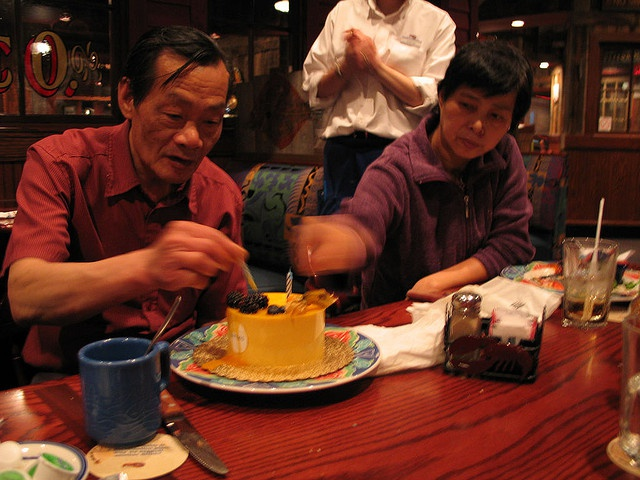Describe the objects in this image and their specific colors. I can see dining table in black, brown, and maroon tones, people in black, maroon, and brown tones, people in black, maroon, and brown tones, people in black, tan, and maroon tones, and cake in black, orange, and red tones in this image. 